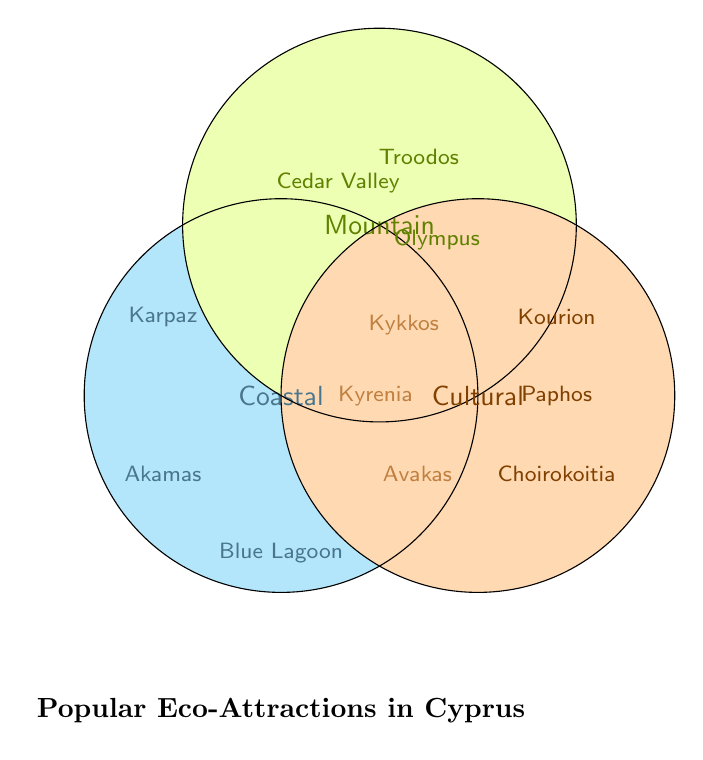How many attractions are categorized under "Coastal"? Count the attractions only appearing within the "Coastal" area of the Venn Diagram. There are three: Blue Lagoon, Akamas Peninsula, and Karpaz Peninsula.
Answer: 3 Which attraction falls under both Coastal and Mountain categories? Check the overlapping section between Coastal and Mountain circles. The attraction here is Avakas Gorge.
Answer: Avakas Gorge What are the attractions listed under the Cultural category? Look at the section labeled "Cultural". The attractions listed are Kourion Archaeological Site, Paphos Mosaics, and Choirokoitia Neolithic Settlement.
Answer: Kourion, Paphos, Choirokoitia Are there any attractions that fall under all three categories at once? Examine if there are any attractions listed within the intersection area of all three sections. No attractions are in the overlapping area of Coastal, Mountain, and Cultural categories.
Answer: No Which attraction is found in both the Coastal and Cultural categories? Check the overlapping area between the Coastal and Cultural sections of the Venn Diagram. The attraction here is Kyrenia Castle.
Answer: Kyrenia Castle How many attractions are in the Mountain category including overlapping ones? Count all attractions within the Mountain section, both unique and overlapping areas. The attractions are Troodos Mountains, Cedar Valley, Mount Olympus, Avakas Gorge (overlap with Coastal), and Kykkos Monastery (overlap with Cultural), totaling five.
Answer: 5 Which area has more unique attractions, Coastal or Cultural? Count the unique attractions in Coastal (Blue Lagoon, Akamas Peninsula, Karpaz Peninsula - 3) and Cultural (Kourion, Paphos, Choirokoitia - 3). Both Coastal and Cultural have three unique attractions each.
Answer: Equal What is one of the attractions that falls into both Mountain and Cultural categories? Look at the area where Mountain and Cultural circles overlap. One example is Kykkos Monastery.
Answer: Kykkos Monastery How many attractions in total are represented in the Venn Diagram? Sum all the attractions listed in the Venn Diagram. The attractions are: Blue Lagoon, Akamas Peninsula, Karpaz Peninsula, Troodos Mountains, Cedar Valley, Mount Olympus, Kourion Archaeological Site, Paphos Mosaics, Choirokoitia Neolithic Settlement, Avakas Gorge, Kyrenia Castle, Kykkos Monastery, making a total of twelve.
Answer: 12 Which categories do not share any common attractions? Identify which sections of the Venn Diagram do not overlap with each other. Coastal and Cultural categories do not have any common non-overlapping attractions.
Answer: Coastal & Cultural 